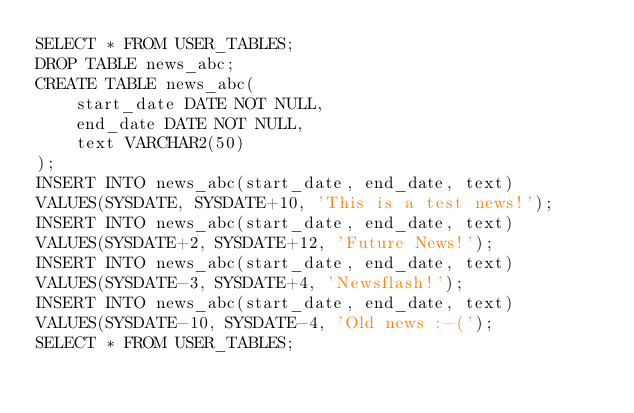<code> <loc_0><loc_0><loc_500><loc_500><_SQL_>SELECT * FROM USER_TABLES;
DROP TABLE news_abc;
CREATE TABLE news_abc(
    start_date DATE NOT NULL,
    end_date DATE NOT NULL,
    text VARCHAR2(50)
);
INSERT INTO news_abc(start_date, end_date, text)
VALUES(SYSDATE, SYSDATE+10, 'This is a test news!');
INSERT INTO news_abc(start_date, end_date, text)
VALUES(SYSDATE+2, SYSDATE+12, 'Future News!');
INSERT INTO news_abc(start_date, end_date, text)
VALUES(SYSDATE-3, SYSDATE+4, 'Newsflash!');
INSERT INTO news_abc(start_date, end_date, text)
VALUES(SYSDATE-10, SYSDATE-4, 'Old news :-(');
SELECT * FROM USER_TABLES;

</code> 